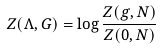<formula> <loc_0><loc_0><loc_500><loc_500>Z ( \Lambda , G ) = \log \frac { Z ( g , N ) } { Z ( 0 , N ) }</formula> 